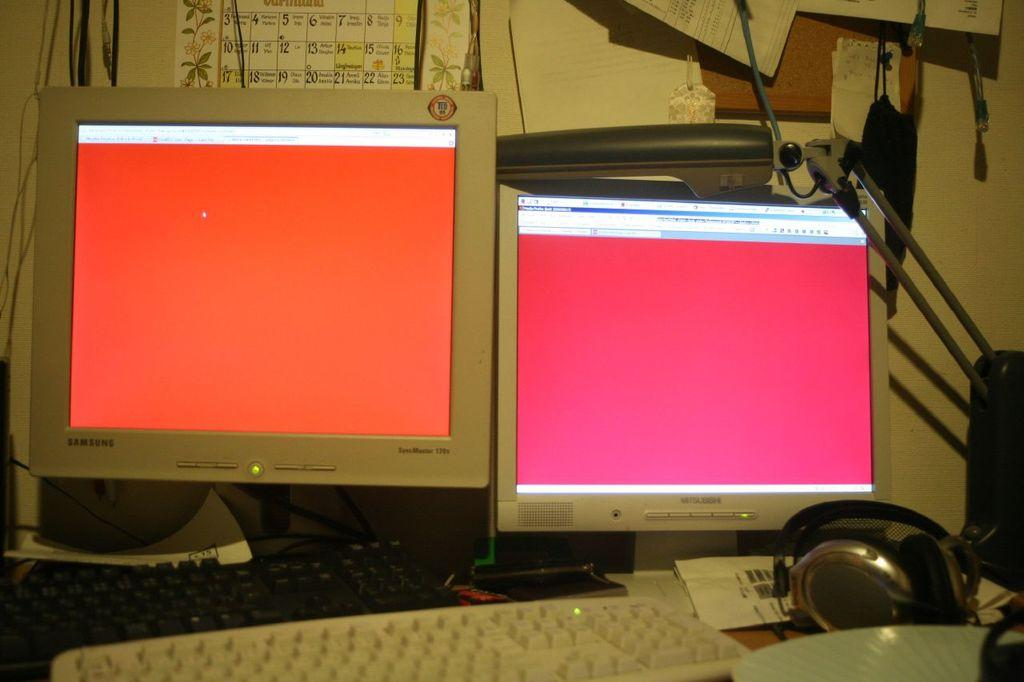<image>
Present a compact description of the photo's key features. A white Samsung monitor is next to another monitor. 